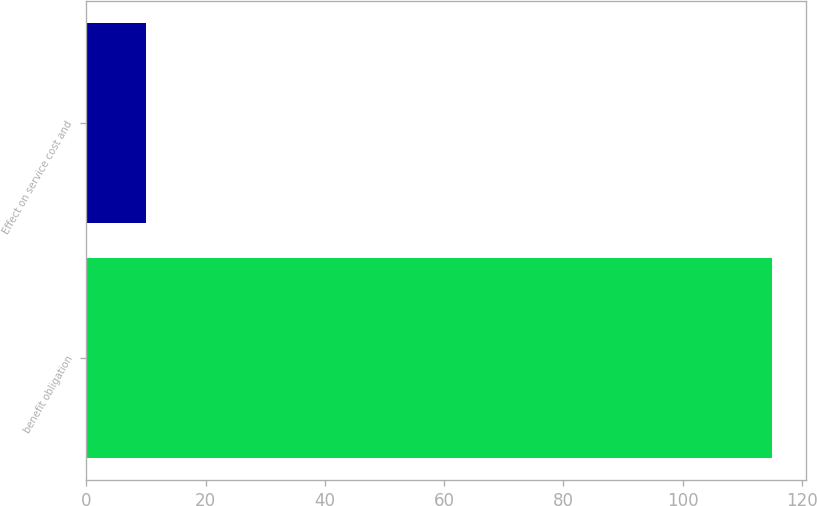Convert chart. <chart><loc_0><loc_0><loc_500><loc_500><bar_chart><fcel>benefit obligation<fcel>Effect on service cost and<nl><fcel>115<fcel>10<nl></chart> 